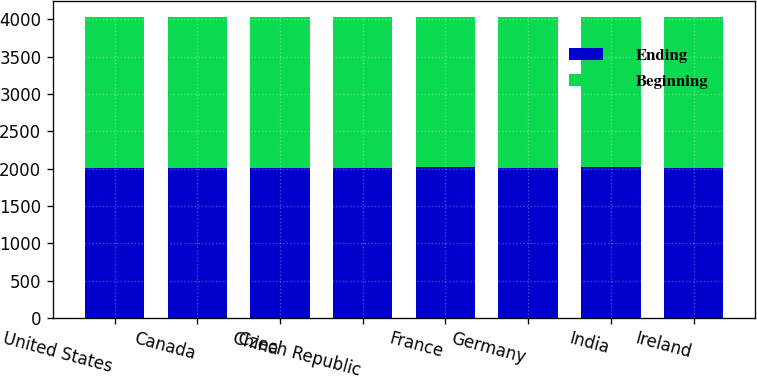<chart> <loc_0><loc_0><loc_500><loc_500><stacked_bar_chart><ecel><fcel>United States<fcel>Canada<fcel>China<fcel>Czech Republic<fcel>France<fcel>Germany<fcel>India<fcel>Ireland<nl><fcel>Ending<fcel>2015<fcel>2014<fcel>2013<fcel>2015<fcel>2016<fcel>2011<fcel>2018<fcel>2014<nl><fcel>Beginning<fcel>2018<fcel>2018<fcel>2018<fcel>2018<fcel>2018<fcel>2018<fcel>2018<fcel>2018<nl></chart> 